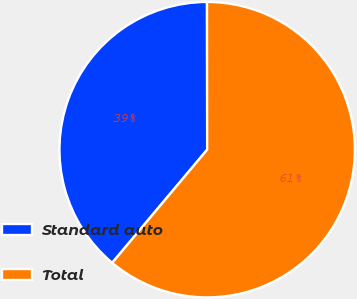<chart> <loc_0><loc_0><loc_500><loc_500><pie_chart><fcel>Standard auto<fcel>Total<nl><fcel>38.87%<fcel>61.13%<nl></chart> 